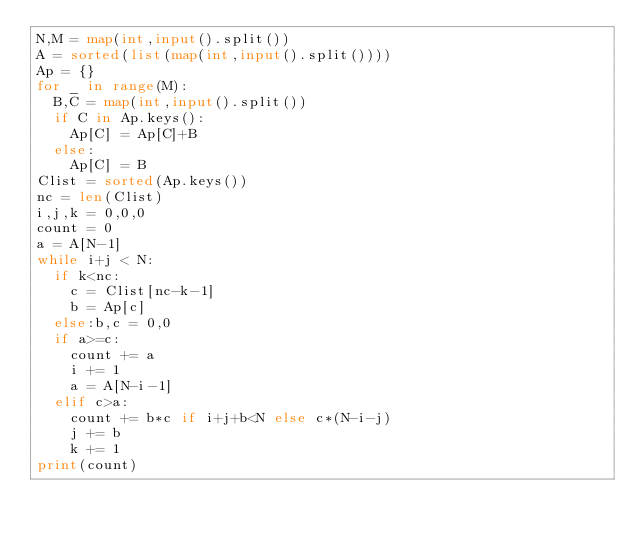Convert code to text. <code><loc_0><loc_0><loc_500><loc_500><_Python_>N,M = map(int,input().split())
A = sorted(list(map(int,input().split())))
Ap = {}
for _ in range(M):
  B,C = map(int,input().split())
  if C in Ap.keys():
    Ap[C] = Ap[C]+B
  else:
    Ap[C] = B
Clist = sorted(Ap.keys())
nc = len(Clist)
i,j,k = 0,0,0
count = 0
a = A[N-1]
while i+j < N:
  if k<nc:
    c = Clist[nc-k-1]
    b = Ap[c]
  else:b,c = 0,0
  if a>=c:
    count += a
    i += 1
    a = A[N-i-1]
  elif c>a:
    count += b*c if i+j+b<N else c*(N-i-j)
    j += b
    k += 1
print(count)</code> 